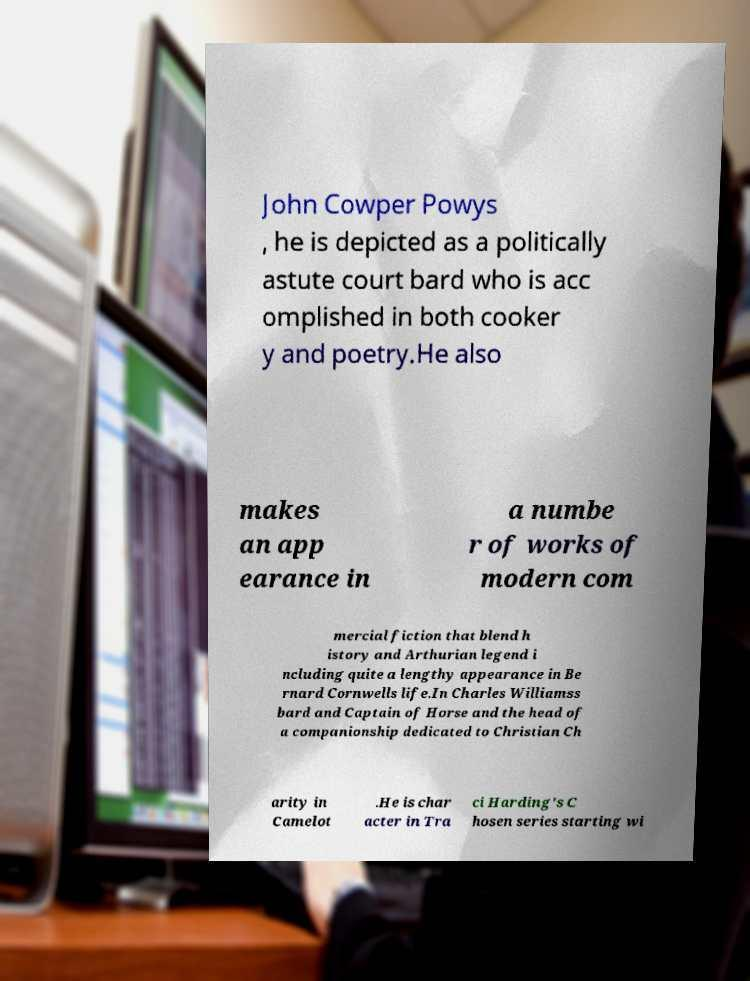Could you extract and type out the text from this image? John Cowper Powys , he is depicted as a politically astute court bard who is acc omplished in both cooker y and poetry.He also makes an app earance in a numbe r of works of modern com mercial fiction that blend h istory and Arthurian legend i ncluding quite a lengthy appearance in Be rnard Cornwells life.In Charles Williamss bard and Captain of Horse and the head of a companionship dedicated to Christian Ch arity in Camelot .He is char acter in Tra ci Harding's C hosen series starting wi 